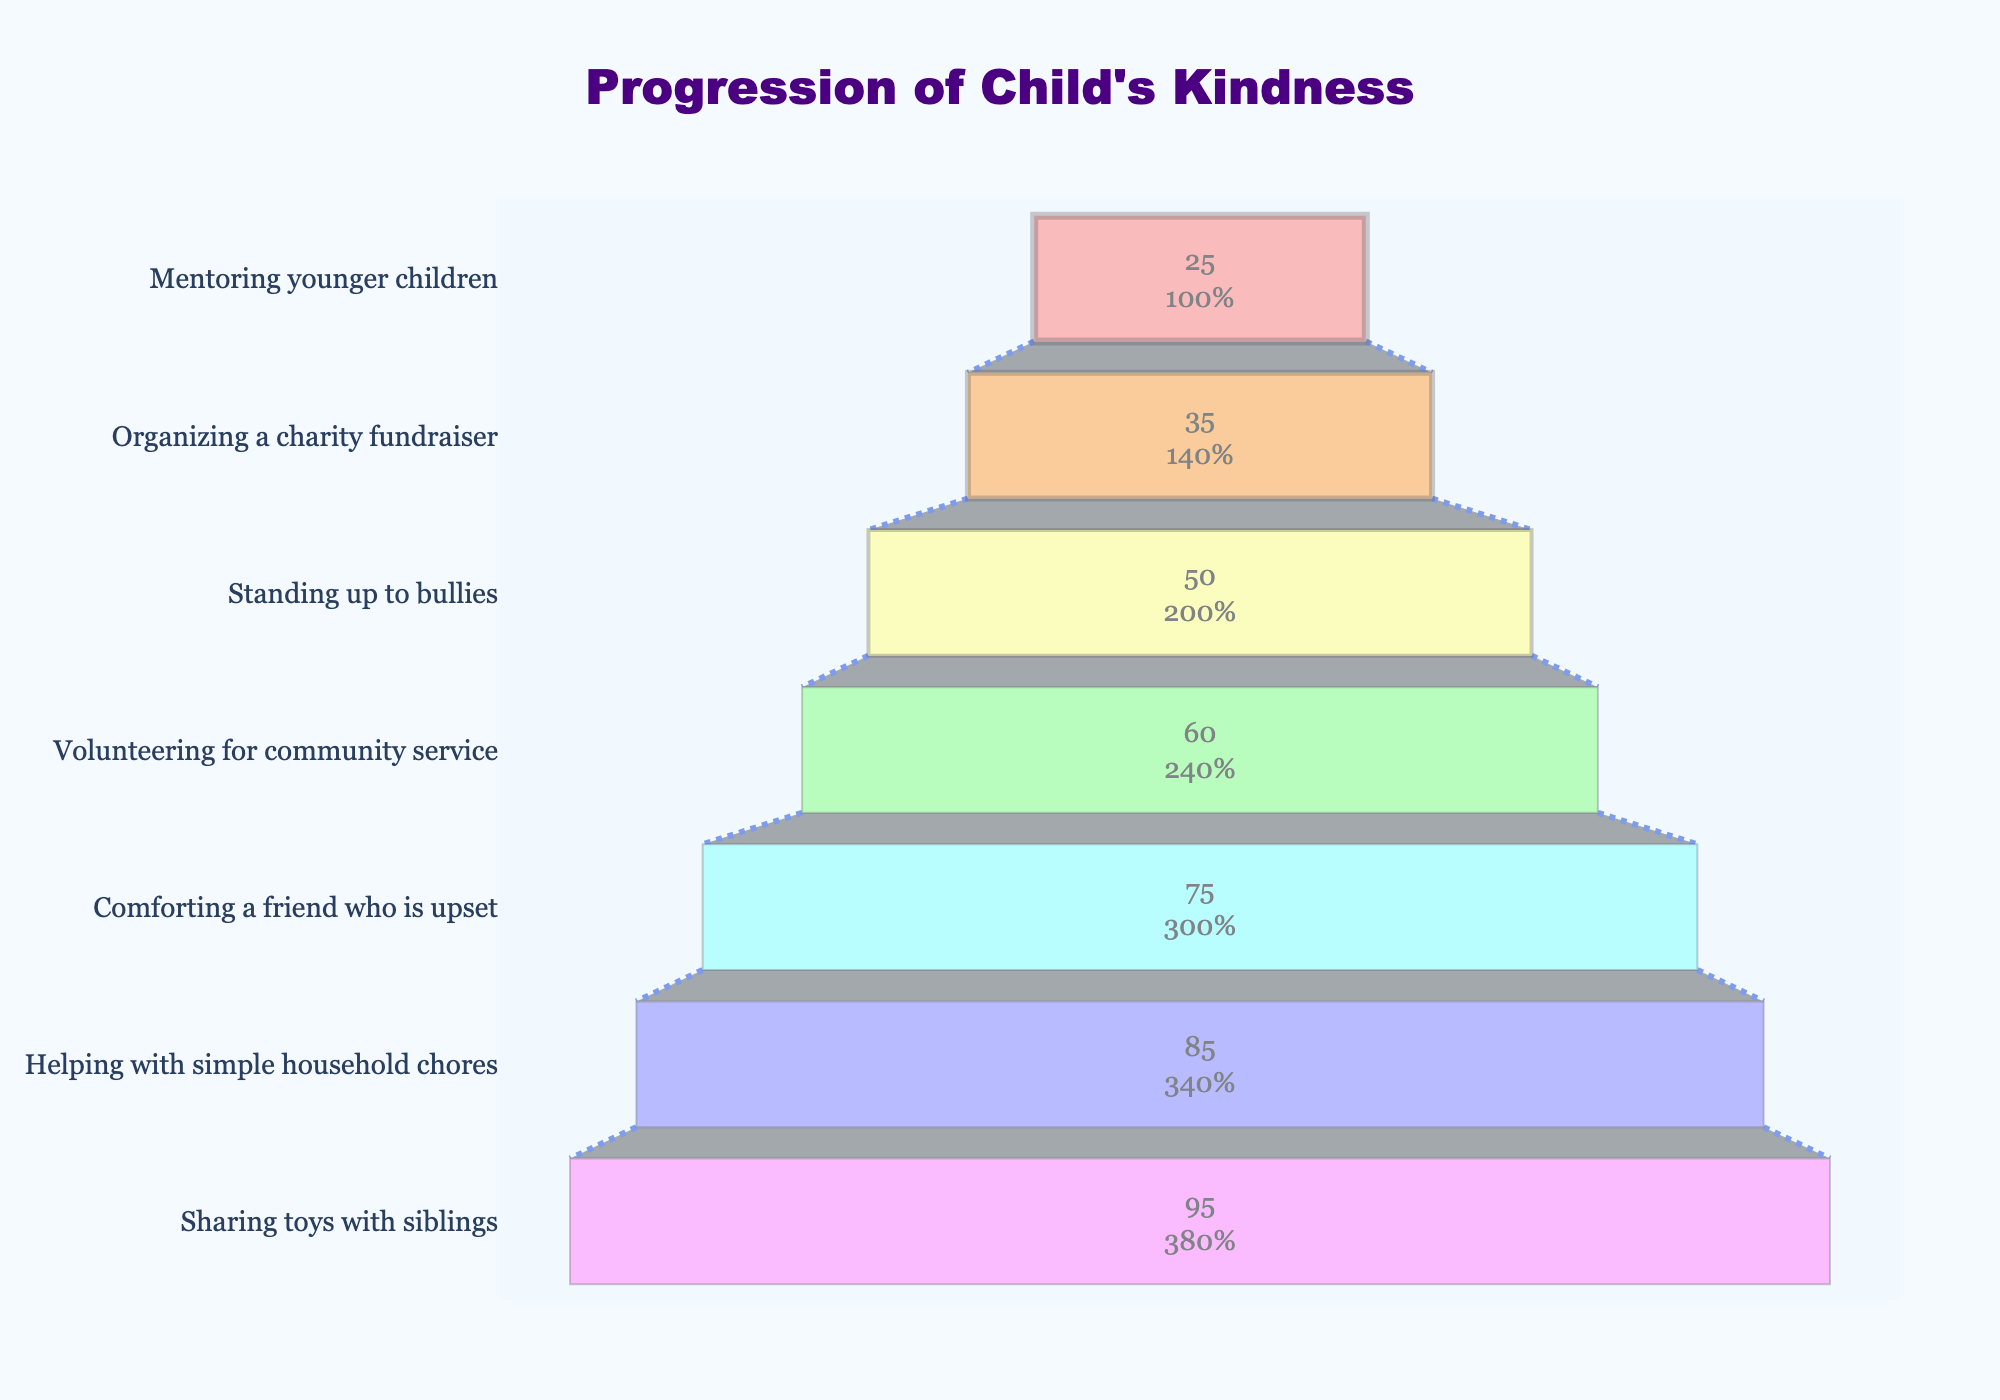What is the title of the funnel chart? The title is given at the top of the figure. It reads "Progression of Child's Kindness".
Answer: Progression of Child's Kindness How many stages are shown in the funnel chart? Each data point represents a stage, and there are 7 distinct stages listed from bottom to top.
Answer: 7 Which stage has the highest percentage of children participating? The topmost stage typically represents the highest percentage. According to the data, the stage "Sharing toys with siblings" has the highest percentage which is 95%.
Answer: Sharing toys with siblings Which stage has the lowest percentage of children participating? The bottommost stage usually represents the lowest percentage. The stage "Mentoring younger children" is at the bottom with a percentage of 25%.
Answer: Mentoring younger children What is the difference in percentage between "Volunteering for community service" and "Standing up to bullies"? The percentage for "Volunteering for community service" is 60% and for "Standing up to bullies" is 50%. The difference is calculated by subtracting the smaller value from the larger one: 60% - 50% = 10%.
Answer: 10% Which act of kindness sees a participation rate of 75%? The figure lists participation percentages next to each stage. The stage "Comforting a friend who is upset" sees a 75% participation rate.
Answer: Comforting a friend who is upset Compare the participation rates between "Helping with simple household chores" and "Standing up to bullies". Which one is higher and by how much? The percentage for "Helping with simple household chores" is 85% and for "Standing up to bullies" is 50%. "Helping with simple household chores" is higher by 85% - 50% = 35%.
Answer: Helping with simple household chores by 35% What is the average percentage of participation across all the stages? To find the average, sum up all the percentages and divide by the number of stages. The sum of percentages is 95 + 85 + 75 + 60 + 50 + 35 + 25 = 425. There are 7 stages, so the average is 425 / 7 = 60.71%.
Answer: 60.71% Between "Organizing a charity fundraiser" and "Comforting a friend who is upset", which stage has a higher participation rate and by what factor? "Organizing a charity fundraiser" has a 35% participation rate while "Comforting a friend who is upset" has 75%. The participation rate of "Comforting a friend who is upset" is higher. The factor is calculated by dividing the higher percentage by the lower percentage: 75 / 35 ≈ 2.14.
Answer: Comforting a friend who is upset by approximately 2.14 Which stage follows "Volunteering for community service" in participation rate hierarchy? The stages are listed in descending order of percentage from bottom to top. "Standing up to bullies" follows "Volunteering for community service", as it has a participation rate of 50%.
Answer: Standing up to bullies 